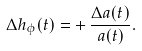Convert formula to latex. <formula><loc_0><loc_0><loc_500><loc_500>\Delta h _ { \phi } ( t ) = + \, \frac { \Delta a ( t ) } { a ( t ) } .</formula> 